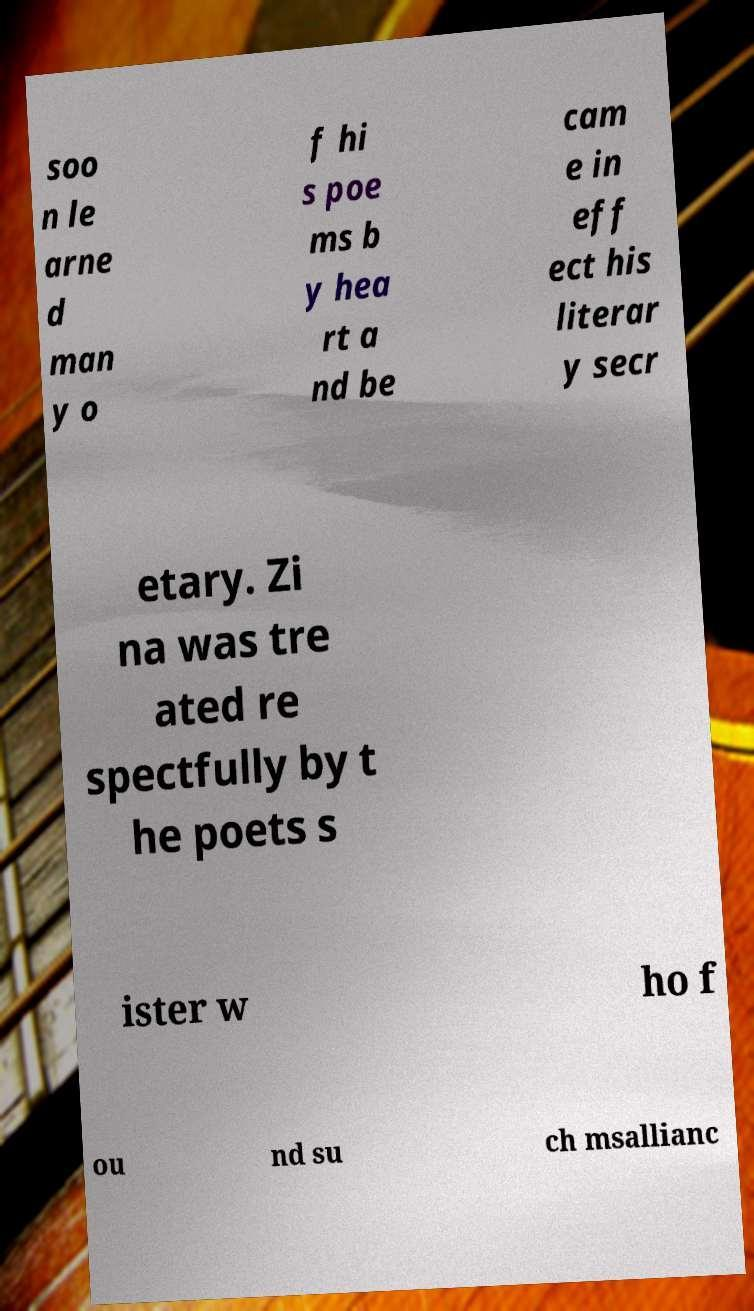Please read and relay the text visible in this image. What does it say? soo n le arne d man y o f hi s poe ms b y hea rt a nd be cam e in eff ect his literar y secr etary. Zi na was tre ated re spectfully by t he poets s ister w ho f ou nd su ch msallianc 